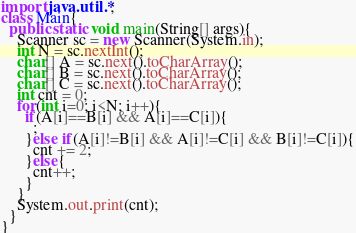Convert code to text. <code><loc_0><loc_0><loc_500><loc_500><_Java_>import java.util.*;
class Main{
  public static void main(String[] args){
    Scanner sc = new Scanner(System.in);
    int N = sc.nextInt();
    char[] A = sc.next().toCharArray();
    char[] B = sc.next().toCharArray();
    char[] C = sc.next().toCharArray();
    int cnt = 0;
    for(int i=0; i<N; i++){
      if(A[i]==B[i] && A[i]==C[i]){
        ;
      }else if(A[i]!=B[i] && A[i]!=C[i] && B[i]!=C[i]){
        cnt += 2;
      }else{
        cnt++;
      }
    }
    System.out.print(cnt);
  }
}
</code> 